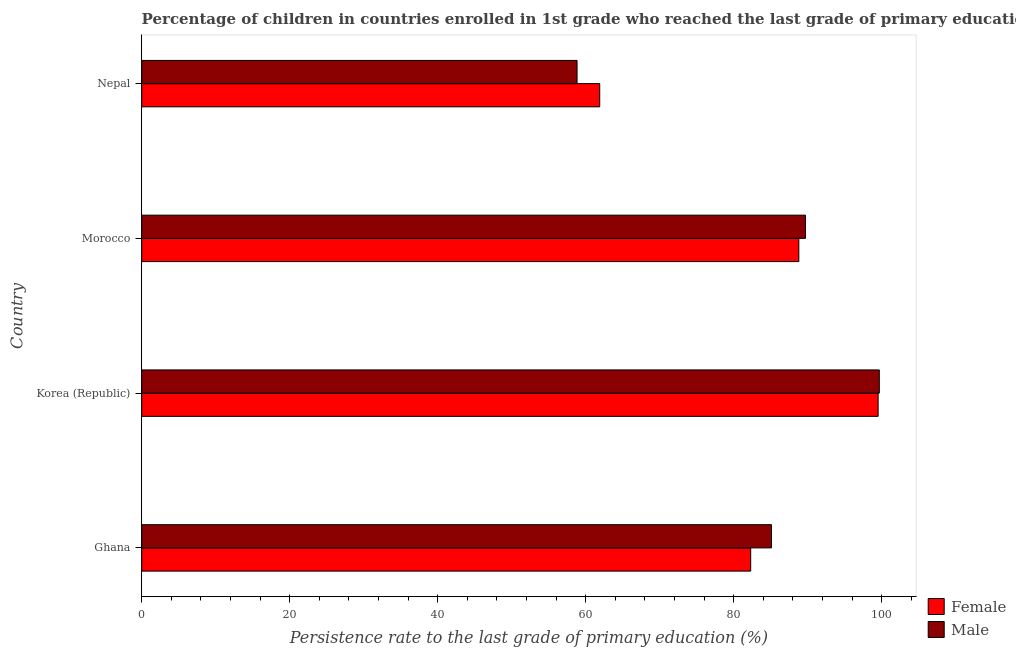How many groups of bars are there?
Your answer should be very brief. 4. Are the number of bars per tick equal to the number of legend labels?
Your response must be concise. Yes. Are the number of bars on each tick of the Y-axis equal?
Offer a very short reply. Yes. How many bars are there on the 3rd tick from the top?
Give a very brief answer. 2. How many bars are there on the 1st tick from the bottom?
Your answer should be very brief. 2. What is the label of the 1st group of bars from the top?
Offer a terse response. Nepal. What is the persistence rate of female students in Morocco?
Ensure brevity in your answer.  88.79. Across all countries, what is the maximum persistence rate of male students?
Your answer should be very brief. 99.67. Across all countries, what is the minimum persistence rate of male students?
Your response must be concise. 58.83. In which country was the persistence rate of female students minimum?
Ensure brevity in your answer.  Nepal. What is the total persistence rate of female students in the graph?
Give a very brief answer. 332.48. What is the difference between the persistence rate of male students in Ghana and that in Nepal?
Give a very brief answer. 26.27. What is the difference between the persistence rate of female students in Korea (Republic) and the persistence rate of male students in Morocco?
Keep it short and to the point. 9.82. What is the average persistence rate of male students per country?
Offer a terse response. 83.32. What is the difference between the persistence rate of male students and persistence rate of female students in Nepal?
Offer a very short reply. -3.06. What is the ratio of the persistence rate of female students in Korea (Republic) to that in Nepal?
Offer a very short reply. 1.61. Is the persistence rate of male students in Ghana less than that in Korea (Republic)?
Offer a very short reply. Yes. Is the difference between the persistence rate of male students in Korea (Republic) and Morocco greater than the difference between the persistence rate of female students in Korea (Republic) and Morocco?
Make the answer very short. No. What is the difference between the highest and the second highest persistence rate of female students?
Provide a succinct answer. 10.72. What is the difference between the highest and the lowest persistence rate of female students?
Your response must be concise. 37.62. How many countries are there in the graph?
Your answer should be compact. 4. Are the values on the major ticks of X-axis written in scientific E-notation?
Keep it short and to the point. No. Does the graph contain any zero values?
Provide a short and direct response. No. How many legend labels are there?
Offer a very short reply. 2. How are the legend labels stacked?
Make the answer very short. Vertical. What is the title of the graph?
Offer a terse response. Percentage of children in countries enrolled in 1st grade who reached the last grade of primary education. Does "RDB concessional" appear as one of the legend labels in the graph?
Ensure brevity in your answer.  No. What is the label or title of the X-axis?
Your answer should be compact. Persistence rate to the last grade of primary education (%). What is the label or title of the Y-axis?
Give a very brief answer. Country. What is the Persistence rate to the last grade of primary education (%) in Female in Ghana?
Offer a very short reply. 82.29. What is the Persistence rate to the last grade of primary education (%) of Male in Ghana?
Provide a succinct answer. 85.1. What is the Persistence rate to the last grade of primary education (%) in Female in Korea (Republic)?
Provide a succinct answer. 99.51. What is the Persistence rate to the last grade of primary education (%) of Male in Korea (Republic)?
Your response must be concise. 99.67. What is the Persistence rate to the last grade of primary education (%) of Female in Morocco?
Your answer should be compact. 88.79. What is the Persistence rate to the last grade of primary education (%) of Male in Morocco?
Provide a short and direct response. 89.69. What is the Persistence rate to the last grade of primary education (%) of Female in Nepal?
Offer a terse response. 61.89. What is the Persistence rate to the last grade of primary education (%) of Male in Nepal?
Offer a very short reply. 58.83. Across all countries, what is the maximum Persistence rate to the last grade of primary education (%) in Female?
Your answer should be very brief. 99.51. Across all countries, what is the maximum Persistence rate to the last grade of primary education (%) of Male?
Your response must be concise. 99.67. Across all countries, what is the minimum Persistence rate to the last grade of primary education (%) of Female?
Offer a very short reply. 61.89. Across all countries, what is the minimum Persistence rate to the last grade of primary education (%) of Male?
Your response must be concise. 58.83. What is the total Persistence rate to the last grade of primary education (%) in Female in the graph?
Ensure brevity in your answer.  332.48. What is the total Persistence rate to the last grade of primary education (%) of Male in the graph?
Your answer should be compact. 333.28. What is the difference between the Persistence rate to the last grade of primary education (%) of Female in Ghana and that in Korea (Republic)?
Your response must be concise. -17.22. What is the difference between the Persistence rate to the last grade of primary education (%) of Male in Ghana and that in Korea (Republic)?
Provide a short and direct response. -14.57. What is the difference between the Persistence rate to the last grade of primary education (%) of Female in Ghana and that in Morocco?
Provide a succinct answer. -6.5. What is the difference between the Persistence rate to the last grade of primary education (%) of Male in Ghana and that in Morocco?
Your answer should be very brief. -4.59. What is the difference between the Persistence rate to the last grade of primary education (%) of Female in Ghana and that in Nepal?
Give a very brief answer. 20.4. What is the difference between the Persistence rate to the last grade of primary education (%) in Male in Ghana and that in Nepal?
Offer a terse response. 26.27. What is the difference between the Persistence rate to the last grade of primary education (%) in Female in Korea (Republic) and that in Morocco?
Your answer should be very brief. 10.72. What is the difference between the Persistence rate to the last grade of primary education (%) in Male in Korea (Republic) and that in Morocco?
Ensure brevity in your answer.  9.98. What is the difference between the Persistence rate to the last grade of primary education (%) in Female in Korea (Republic) and that in Nepal?
Your answer should be compact. 37.62. What is the difference between the Persistence rate to the last grade of primary education (%) of Male in Korea (Republic) and that in Nepal?
Provide a succinct answer. 40.84. What is the difference between the Persistence rate to the last grade of primary education (%) of Female in Morocco and that in Nepal?
Give a very brief answer. 26.9. What is the difference between the Persistence rate to the last grade of primary education (%) in Male in Morocco and that in Nepal?
Offer a very short reply. 30.86. What is the difference between the Persistence rate to the last grade of primary education (%) of Female in Ghana and the Persistence rate to the last grade of primary education (%) of Male in Korea (Republic)?
Provide a short and direct response. -17.38. What is the difference between the Persistence rate to the last grade of primary education (%) of Female in Ghana and the Persistence rate to the last grade of primary education (%) of Male in Morocco?
Your answer should be very brief. -7.4. What is the difference between the Persistence rate to the last grade of primary education (%) in Female in Ghana and the Persistence rate to the last grade of primary education (%) in Male in Nepal?
Offer a very short reply. 23.46. What is the difference between the Persistence rate to the last grade of primary education (%) in Female in Korea (Republic) and the Persistence rate to the last grade of primary education (%) in Male in Morocco?
Make the answer very short. 9.82. What is the difference between the Persistence rate to the last grade of primary education (%) of Female in Korea (Republic) and the Persistence rate to the last grade of primary education (%) of Male in Nepal?
Give a very brief answer. 40.68. What is the difference between the Persistence rate to the last grade of primary education (%) in Female in Morocco and the Persistence rate to the last grade of primary education (%) in Male in Nepal?
Provide a short and direct response. 29.97. What is the average Persistence rate to the last grade of primary education (%) in Female per country?
Your answer should be very brief. 83.12. What is the average Persistence rate to the last grade of primary education (%) in Male per country?
Provide a short and direct response. 83.32. What is the difference between the Persistence rate to the last grade of primary education (%) in Female and Persistence rate to the last grade of primary education (%) in Male in Ghana?
Ensure brevity in your answer.  -2.81. What is the difference between the Persistence rate to the last grade of primary education (%) in Female and Persistence rate to the last grade of primary education (%) in Male in Korea (Republic)?
Your answer should be very brief. -0.16. What is the difference between the Persistence rate to the last grade of primary education (%) in Female and Persistence rate to the last grade of primary education (%) in Male in Morocco?
Give a very brief answer. -0.9. What is the difference between the Persistence rate to the last grade of primary education (%) of Female and Persistence rate to the last grade of primary education (%) of Male in Nepal?
Give a very brief answer. 3.06. What is the ratio of the Persistence rate to the last grade of primary education (%) in Female in Ghana to that in Korea (Republic)?
Ensure brevity in your answer.  0.83. What is the ratio of the Persistence rate to the last grade of primary education (%) of Male in Ghana to that in Korea (Republic)?
Make the answer very short. 0.85. What is the ratio of the Persistence rate to the last grade of primary education (%) of Female in Ghana to that in Morocco?
Ensure brevity in your answer.  0.93. What is the ratio of the Persistence rate to the last grade of primary education (%) in Male in Ghana to that in Morocco?
Your answer should be very brief. 0.95. What is the ratio of the Persistence rate to the last grade of primary education (%) of Female in Ghana to that in Nepal?
Your answer should be very brief. 1.33. What is the ratio of the Persistence rate to the last grade of primary education (%) in Male in Ghana to that in Nepal?
Provide a succinct answer. 1.45. What is the ratio of the Persistence rate to the last grade of primary education (%) of Female in Korea (Republic) to that in Morocco?
Give a very brief answer. 1.12. What is the ratio of the Persistence rate to the last grade of primary education (%) of Male in Korea (Republic) to that in Morocco?
Keep it short and to the point. 1.11. What is the ratio of the Persistence rate to the last grade of primary education (%) in Female in Korea (Republic) to that in Nepal?
Give a very brief answer. 1.61. What is the ratio of the Persistence rate to the last grade of primary education (%) of Male in Korea (Republic) to that in Nepal?
Keep it short and to the point. 1.69. What is the ratio of the Persistence rate to the last grade of primary education (%) in Female in Morocco to that in Nepal?
Your response must be concise. 1.43. What is the ratio of the Persistence rate to the last grade of primary education (%) in Male in Morocco to that in Nepal?
Keep it short and to the point. 1.52. What is the difference between the highest and the second highest Persistence rate to the last grade of primary education (%) in Female?
Give a very brief answer. 10.72. What is the difference between the highest and the second highest Persistence rate to the last grade of primary education (%) in Male?
Provide a short and direct response. 9.98. What is the difference between the highest and the lowest Persistence rate to the last grade of primary education (%) in Female?
Offer a very short reply. 37.62. What is the difference between the highest and the lowest Persistence rate to the last grade of primary education (%) of Male?
Offer a very short reply. 40.84. 